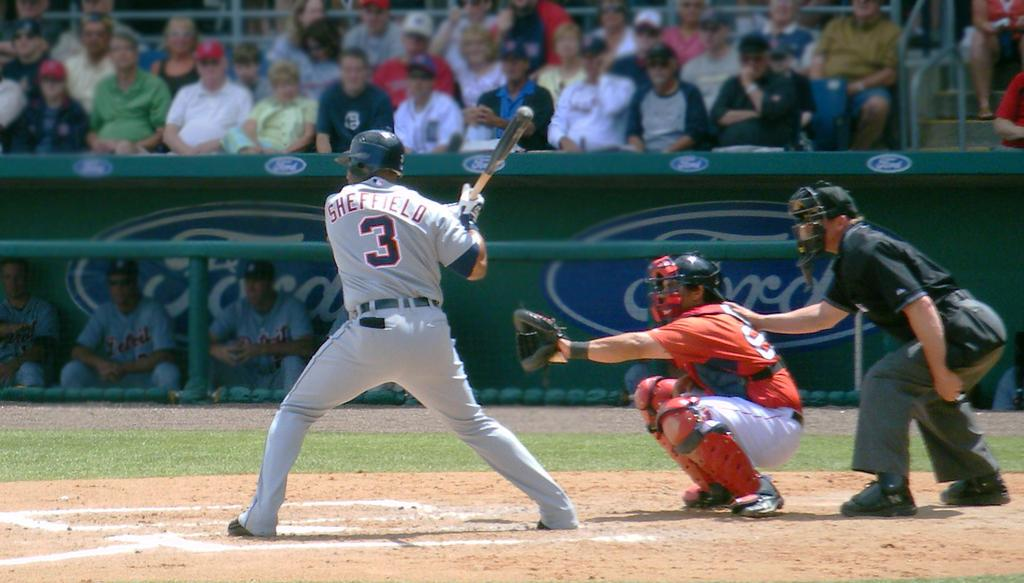<image>
Describe the image concisely. A baseball player with the name Sheffield 3 on his jersey is holding a bat at a Ford playing field. 